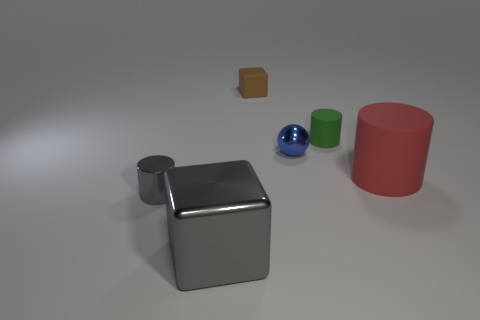Does this image seem to represent something from everyday life? Not exactly; the image appears to be more of a staged composition, likely intended to visually present various geometric shapes and materials. The simplicity and isolation of the objects could also suggest a digital rendering for a graphical test or demonstration rather than a scene from everyday life. 